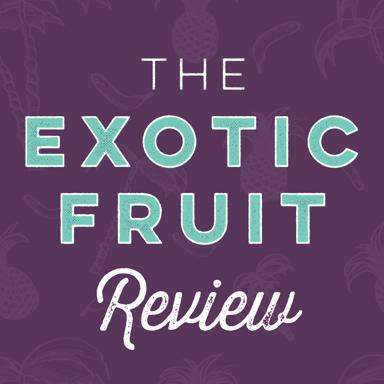What is the main theme of the image? The main theme of the image is an exotic fruit review. The central visual element is a pineapple set against a vibrant purple background, complemented by stylish text that reads 'The Exotic Fruit Review'. This combination suggests a focus on discussing or evaluating tropical fruits. 